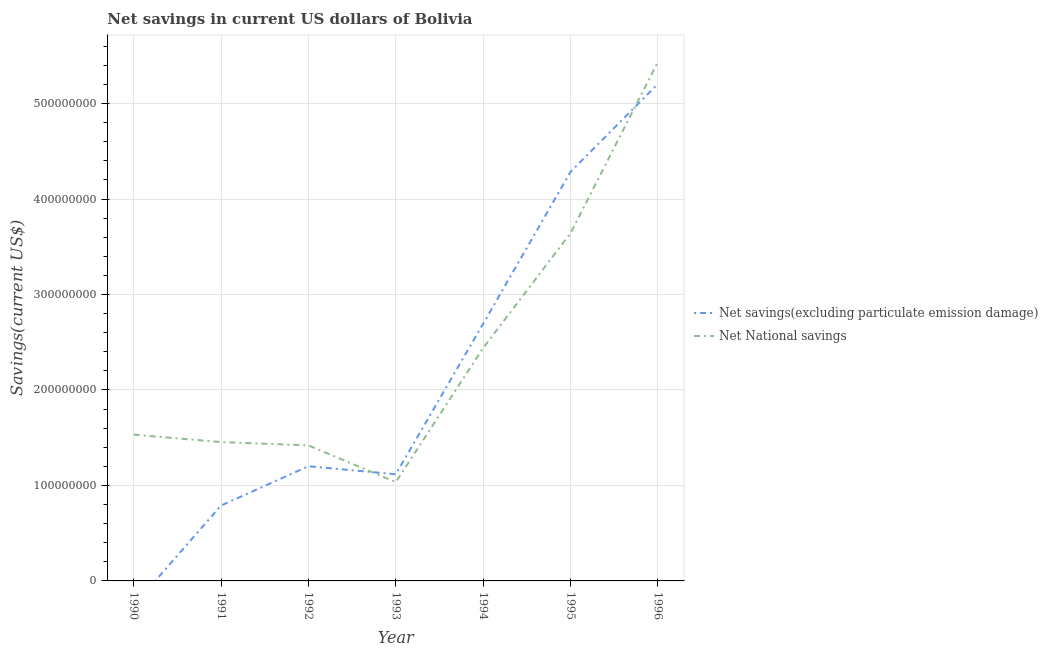Is the number of lines equal to the number of legend labels?
Provide a succinct answer. No. What is the net national savings in 1992?
Your response must be concise. 1.42e+08. Across all years, what is the maximum net national savings?
Ensure brevity in your answer.  5.43e+08. Across all years, what is the minimum net national savings?
Your answer should be compact. 1.03e+08. What is the total net national savings in the graph?
Provide a short and direct response. 1.70e+09. What is the difference between the net savings(excluding particulate emission damage) in 1993 and that in 1995?
Your answer should be very brief. -3.17e+08. What is the difference between the net national savings in 1994 and the net savings(excluding particulate emission damage) in 1990?
Your answer should be very brief. 2.44e+08. What is the average net national savings per year?
Provide a short and direct response. 2.42e+08. In the year 1993, what is the difference between the net national savings and net savings(excluding particulate emission damage)?
Offer a terse response. -8.23e+06. In how many years, is the net national savings greater than 520000000 US$?
Keep it short and to the point. 1. What is the ratio of the net national savings in 1994 to that in 1995?
Your answer should be very brief. 0.67. Is the difference between the net savings(excluding particulate emission damage) in 1991 and 1995 greater than the difference between the net national savings in 1991 and 1995?
Your response must be concise. No. What is the difference between the highest and the second highest net national savings?
Offer a terse response. 1.79e+08. What is the difference between the highest and the lowest net national savings?
Your answer should be compact. 4.40e+08. Is the sum of the net national savings in 1994 and 1995 greater than the maximum net savings(excluding particulate emission damage) across all years?
Keep it short and to the point. Yes. Does the net savings(excluding particulate emission damage) monotonically increase over the years?
Provide a short and direct response. No. Is the net national savings strictly greater than the net savings(excluding particulate emission damage) over the years?
Ensure brevity in your answer.  No. Is the net savings(excluding particulate emission damage) strictly less than the net national savings over the years?
Offer a terse response. No. How many lines are there?
Provide a short and direct response. 2. What is the difference between two consecutive major ticks on the Y-axis?
Offer a terse response. 1.00e+08. Where does the legend appear in the graph?
Your answer should be compact. Center right. How many legend labels are there?
Offer a very short reply. 2. How are the legend labels stacked?
Keep it short and to the point. Vertical. What is the title of the graph?
Ensure brevity in your answer.  Net savings in current US dollars of Bolivia. What is the label or title of the X-axis?
Offer a very short reply. Year. What is the label or title of the Y-axis?
Provide a succinct answer. Savings(current US$). What is the Savings(current US$) in Net National savings in 1990?
Your answer should be very brief. 1.53e+08. What is the Savings(current US$) in Net savings(excluding particulate emission damage) in 1991?
Make the answer very short. 7.90e+07. What is the Savings(current US$) in Net National savings in 1991?
Your response must be concise. 1.45e+08. What is the Savings(current US$) of Net savings(excluding particulate emission damage) in 1992?
Give a very brief answer. 1.20e+08. What is the Savings(current US$) in Net National savings in 1992?
Your answer should be compact. 1.42e+08. What is the Savings(current US$) in Net savings(excluding particulate emission damage) in 1993?
Your response must be concise. 1.12e+08. What is the Savings(current US$) of Net National savings in 1993?
Keep it short and to the point. 1.03e+08. What is the Savings(current US$) in Net savings(excluding particulate emission damage) in 1994?
Make the answer very short. 2.69e+08. What is the Savings(current US$) of Net National savings in 1994?
Ensure brevity in your answer.  2.44e+08. What is the Savings(current US$) of Net savings(excluding particulate emission damage) in 1995?
Your response must be concise. 4.28e+08. What is the Savings(current US$) of Net National savings in 1995?
Offer a very short reply. 3.64e+08. What is the Savings(current US$) in Net savings(excluding particulate emission damage) in 1996?
Keep it short and to the point. 5.21e+08. What is the Savings(current US$) of Net National savings in 1996?
Ensure brevity in your answer.  5.43e+08. Across all years, what is the maximum Savings(current US$) of Net savings(excluding particulate emission damage)?
Give a very brief answer. 5.21e+08. Across all years, what is the maximum Savings(current US$) in Net National savings?
Your response must be concise. 5.43e+08. Across all years, what is the minimum Savings(current US$) in Net National savings?
Provide a succinct answer. 1.03e+08. What is the total Savings(current US$) of Net savings(excluding particulate emission damage) in the graph?
Provide a succinct answer. 1.53e+09. What is the total Savings(current US$) in Net National savings in the graph?
Offer a very short reply. 1.70e+09. What is the difference between the Savings(current US$) in Net National savings in 1990 and that in 1991?
Make the answer very short. 7.78e+06. What is the difference between the Savings(current US$) of Net National savings in 1990 and that in 1992?
Make the answer very short. 1.13e+07. What is the difference between the Savings(current US$) in Net National savings in 1990 and that in 1993?
Make the answer very short. 4.98e+07. What is the difference between the Savings(current US$) of Net National savings in 1990 and that in 1994?
Offer a very short reply. -9.08e+07. What is the difference between the Savings(current US$) in Net National savings in 1990 and that in 1995?
Give a very brief answer. -2.11e+08. What is the difference between the Savings(current US$) of Net National savings in 1990 and that in 1996?
Your answer should be very brief. -3.90e+08. What is the difference between the Savings(current US$) of Net savings(excluding particulate emission damage) in 1991 and that in 1992?
Your answer should be compact. -4.12e+07. What is the difference between the Savings(current US$) in Net National savings in 1991 and that in 1992?
Make the answer very short. 3.48e+06. What is the difference between the Savings(current US$) in Net savings(excluding particulate emission damage) in 1991 and that in 1993?
Offer a terse response. -3.27e+07. What is the difference between the Savings(current US$) in Net National savings in 1991 and that in 1993?
Offer a terse response. 4.20e+07. What is the difference between the Savings(current US$) in Net savings(excluding particulate emission damage) in 1991 and that in 1994?
Make the answer very short. -1.90e+08. What is the difference between the Savings(current US$) in Net National savings in 1991 and that in 1994?
Your answer should be compact. -9.85e+07. What is the difference between the Savings(current US$) of Net savings(excluding particulate emission damage) in 1991 and that in 1995?
Your answer should be compact. -3.49e+08. What is the difference between the Savings(current US$) in Net National savings in 1991 and that in 1995?
Your answer should be very brief. -2.19e+08. What is the difference between the Savings(current US$) of Net savings(excluding particulate emission damage) in 1991 and that in 1996?
Make the answer very short. -4.42e+08. What is the difference between the Savings(current US$) in Net National savings in 1991 and that in 1996?
Ensure brevity in your answer.  -3.98e+08. What is the difference between the Savings(current US$) of Net savings(excluding particulate emission damage) in 1992 and that in 1993?
Your answer should be very brief. 8.44e+06. What is the difference between the Savings(current US$) in Net National savings in 1992 and that in 1993?
Ensure brevity in your answer.  3.85e+07. What is the difference between the Savings(current US$) of Net savings(excluding particulate emission damage) in 1992 and that in 1994?
Your response must be concise. -1.49e+08. What is the difference between the Savings(current US$) in Net National savings in 1992 and that in 1994?
Provide a short and direct response. -1.02e+08. What is the difference between the Savings(current US$) of Net savings(excluding particulate emission damage) in 1992 and that in 1995?
Keep it short and to the point. -3.08e+08. What is the difference between the Savings(current US$) in Net National savings in 1992 and that in 1995?
Offer a very short reply. -2.22e+08. What is the difference between the Savings(current US$) of Net savings(excluding particulate emission damage) in 1992 and that in 1996?
Your answer should be very brief. -4.00e+08. What is the difference between the Savings(current US$) in Net National savings in 1992 and that in 1996?
Make the answer very short. -4.01e+08. What is the difference between the Savings(current US$) of Net savings(excluding particulate emission damage) in 1993 and that in 1994?
Offer a terse response. -1.58e+08. What is the difference between the Savings(current US$) in Net National savings in 1993 and that in 1994?
Give a very brief answer. -1.41e+08. What is the difference between the Savings(current US$) in Net savings(excluding particulate emission damage) in 1993 and that in 1995?
Give a very brief answer. -3.17e+08. What is the difference between the Savings(current US$) in Net National savings in 1993 and that in 1995?
Offer a very short reply. -2.61e+08. What is the difference between the Savings(current US$) of Net savings(excluding particulate emission damage) in 1993 and that in 1996?
Your answer should be compact. -4.09e+08. What is the difference between the Savings(current US$) in Net National savings in 1993 and that in 1996?
Your answer should be compact. -4.40e+08. What is the difference between the Savings(current US$) in Net savings(excluding particulate emission damage) in 1994 and that in 1995?
Your response must be concise. -1.59e+08. What is the difference between the Savings(current US$) of Net National savings in 1994 and that in 1995?
Your answer should be compact. -1.20e+08. What is the difference between the Savings(current US$) of Net savings(excluding particulate emission damage) in 1994 and that in 1996?
Your answer should be very brief. -2.51e+08. What is the difference between the Savings(current US$) in Net National savings in 1994 and that in 1996?
Ensure brevity in your answer.  -2.99e+08. What is the difference between the Savings(current US$) in Net savings(excluding particulate emission damage) in 1995 and that in 1996?
Your answer should be compact. -9.21e+07. What is the difference between the Savings(current US$) of Net National savings in 1995 and that in 1996?
Ensure brevity in your answer.  -1.79e+08. What is the difference between the Savings(current US$) of Net savings(excluding particulate emission damage) in 1991 and the Savings(current US$) of Net National savings in 1992?
Offer a very short reply. -6.30e+07. What is the difference between the Savings(current US$) in Net savings(excluding particulate emission damage) in 1991 and the Savings(current US$) in Net National savings in 1993?
Offer a terse response. -2.45e+07. What is the difference between the Savings(current US$) in Net savings(excluding particulate emission damage) in 1991 and the Savings(current US$) in Net National savings in 1994?
Your response must be concise. -1.65e+08. What is the difference between the Savings(current US$) in Net savings(excluding particulate emission damage) in 1991 and the Savings(current US$) in Net National savings in 1995?
Your response must be concise. -2.85e+08. What is the difference between the Savings(current US$) of Net savings(excluding particulate emission damage) in 1991 and the Savings(current US$) of Net National savings in 1996?
Your answer should be very brief. -4.65e+08. What is the difference between the Savings(current US$) in Net savings(excluding particulate emission damage) in 1992 and the Savings(current US$) in Net National savings in 1993?
Provide a short and direct response. 1.67e+07. What is the difference between the Savings(current US$) of Net savings(excluding particulate emission damage) in 1992 and the Savings(current US$) of Net National savings in 1994?
Your answer should be compact. -1.24e+08. What is the difference between the Savings(current US$) of Net savings(excluding particulate emission damage) in 1992 and the Savings(current US$) of Net National savings in 1995?
Keep it short and to the point. -2.44e+08. What is the difference between the Savings(current US$) in Net savings(excluding particulate emission damage) in 1992 and the Savings(current US$) in Net National savings in 1996?
Your response must be concise. -4.23e+08. What is the difference between the Savings(current US$) of Net savings(excluding particulate emission damage) in 1993 and the Savings(current US$) of Net National savings in 1994?
Your answer should be compact. -1.32e+08. What is the difference between the Savings(current US$) in Net savings(excluding particulate emission damage) in 1993 and the Savings(current US$) in Net National savings in 1995?
Ensure brevity in your answer.  -2.52e+08. What is the difference between the Savings(current US$) of Net savings(excluding particulate emission damage) in 1993 and the Savings(current US$) of Net National savings in 1996?
Your answer should be compact. -4.32e+08. What is the difference between the Savings(current US$) of Net savings(excluding particulate emission damage) in 1994 and the Savings(current US$) of Net National savings in 1995?
Make the answer very short. -9.47e+07. What is the difference between the Savings(current US$) in Net savings(excluding particulate emission damage) in 1994 and the Savings(current US$) in Net National savings in 1996?
Make the answer very short. -2.74e+08. What is the difference between the Savings(current US$) in Net savings(excluding particulate emission damage) in 1995 and the Savings(current US$) in Net National savings in 1996?
Keep it short and to the point. -1.15e+08. What is the average Savings(current US$) of Net savings(excluding particulate emission damage) per year?
Keep it short and to the point. 2.18e+08. What is the average Savings(current US$) of Net National savings per year?
Make the answer very short. 2.42e+08. In the year 1991, what is the difference between the Savings(current US$) in Net savings(excluding particulate emission damage) and Savings(current US$) in Net National savings?
Give a very brief answer. -6.65e+07. In the year 1992, what is the difference between the Savings(current US$) of Net savings(excluding particulate emission damage) and Savings(current US$) of Net National savings?
Offer a terse response. -2.18e+07. In the year 1993, what is the difference between the Savings(current US$) of Net savings(excluding particulate emission damage) and Savings(current US$) of Net National savings?
Your response must be concise. 8.23e+06. In the year 1994, what is the difference between the Savings(current US$) in Net savings(excluding particulate emission damage) and Savings(current US$) in Net National savings?
Make the answer very short. 2.54e+07. In the year 1995, what is the difference between the Savings(current US$) in Net savings(excluding particulate emission damage) and Savings(current US$) in Net National savings?
Ensure brevity in your answer.  6.43e+07. In the year 1996, what is the difference between the Savings(current US$) of Net savings(excluding particulate emission damage) and Savings(current US$) of Net National savings?
Offer a very short reply. -2.29e+07. What is the ratio of the Savings(current US$) of Net National savings in 1990 to that in 1991?
Your answer should be compact. 1.05. What is the ratio of the Savings(current US$) in Net National savings in 1990 to that in 1992?
Keep it short and to the point. 1.08. What is the ratio of the Savings(current US$) in Net National savings in 1990 to that in 1993?
Offer a terse response. 1.48. What is the ratio of the Savings(current US$) of Net National savings in 1990 to that in 1994?
Ensure brevity in your answer.  0.63. What is the ratio of the Savings(current US$) of Net National savings in 1990 to that in 1995?
Your response must be concise. 0.42. What is the ratio of the Savings(current US$) in Net National savings in 1990 to that in 1996?
Make the answer very short. 0.28. What is the ratio of the Savings(current US$) in Net savings(excluding particulate emission damage) in 1991 to that in 1992?
Your answer should be very brief. 0.66. What is the ratio of the Savings(current US$) in Net National savings in 1991 to that in 1992?
Make the answer very short. 1.02. What is the ratio of the Savings(current US$) of Net savings(excluding particulate emission damage) in 1991 to that in 1993?
Give a very brief answer. 0.71. What is the ratio of the Savings(current US$) in Net National savings in 1991 to that in 1993?
Your response must be concise. 1.41. What is the ratio of the Savings(current US$) in Net savings(excluding particulate emission damage) in 1991 to that in 1994?
Provide a short and direct response. 0.29. What is the ratio of the Savings(current US$) in Net National savings in 1991 to that in 1994?
Keep it short and to the point. 0.6. What is the ratio of the Savings(current US$) in Net savings(excluding particulate emission damage) in 1991 to that in 1995?
Provide a short and direct response. 0.18. What is the ratio of the Savings(current US$) in Net National savings in 1991 to that in 1995?
Your response must be concise. 0.4. What is the ratio of the Savings(current US$) in Net savings(excluding particulate emission damage) in 1991 to that in 1996?
Keep it short and to the point. 0.15. What is the ratio of the Savings(current US$) in Net National savings in 1991 to that in 1996?
Offer a terse response. 0.27. What is the ratio of the Savings(current US$) of Net savings(excluding particulate emission damage) in 1992 to that in 1993?
Offer a terse response. 1.08. What is the ratio of the Savings(current US$) in Net National savings in 1992 to that in 1993?
Ensure brevity in your answer.  1.37. What is the ratio of the Savings(current US$) in Net savings(excluding particulate emission damage) in 1992 to that in 1994?
Offer a very short reply. 0.45. What is the ratio of the Savings(current US$) in Net National savings in 1992 to that in 1994?
Offer a very short reply. 0.58. What is the ratio of the Savings(current US$) in Net savings(excluding particulate emission damage) in 1992 to that in 1995?
Your answer should be very brief. 0.28. What is the ratio of the Savings(current US$) of Net National savings in 1992 to that in 1995?
Ensure brevity in your answer.  0.39. What is the ratio of the Savings(current US$) in Net savings(excluding particulate emission damage) in 1992 to that in 1996?
Offer a very short reply. 0.23. What is the ratio of the Savings(current US$) in Net National savings in 1992 to that in 1996?
Your answer should be very brief. 0.26. What is the ratio of the Savings(current US$) in Net savings(excluding particulate emission damage) in 1993 to that in 1994?
Offer a very short reply. 0.41. What is the ratio of the Savings(current US$) in Net National savings in 1993 to that in 1994?
Your answer should be very brief. 0.42. What is the ratio of the Savings(current US$) in Net savings(excluding particulate emission damage) in 1993 to that in 1995?
Your response must be concise. 0.26. What is the ratio of the Savings(current US$) in Net National savings in 1993 to that in 1995?
Provide a succinct answer. 0.28. What is the ratio of the Savings(current US$) in Net savings(excluding particulate emission damage) in 1993 to that in 1996?
Make the answer very short. 0.21. What is the ratio of the Savings(current US$) in Net National savings in 1993 to that in 1996?
Your answer should be compact. 0.19. What is the ratio of the Savings(current US$) in Net savings(excluding particulate emission damage) in 1994 to that in 1995?
Ensure brevity in your answer.  0.63. What is the ratio of the Savings(current US$) in Net National savings in 1994 to that in 1995?
Keep it short and to the point. 0.67. What is the ratio of the Savings(current US$) in Net savings(excluding particulate emission damage) in 1994 to that in 1996?
Offer a very short reply. 0.52. What is the ratio of the Savings(current US$) of Net National savings in 1994 to that in 1996?
Give a very brief answer. 0.45. What is the ratio of the Savings(current US$) in Net savings(excluding particulate emission damage) in 1995 to that in 1996?
Provide a succinct answer. 0.82. What is the ratio of the Savings(current US$) in Net National savings in 1995 to that in 1996?
Your answer should be very brief. 0.67. What is the difference between the highest and the second highest Savings(current US$) in Net savings(excluding particulate emission damage)?
Keep it short and to the point. 9.21e+07. What is the difference between the highest and the second highest Savings(current US$) of Net National savings?
Offer a terse response. 1.79e+08. What is the difference between the highest and the lowest Savings(current US$) in Net savings(excluding particulate emission damage)?
Make the answer very short. 5.21e+08. What is the difference between the highest and the lowest Savings(current US$) in Net National savings?
Make the answer very short. 4.40e+08. 